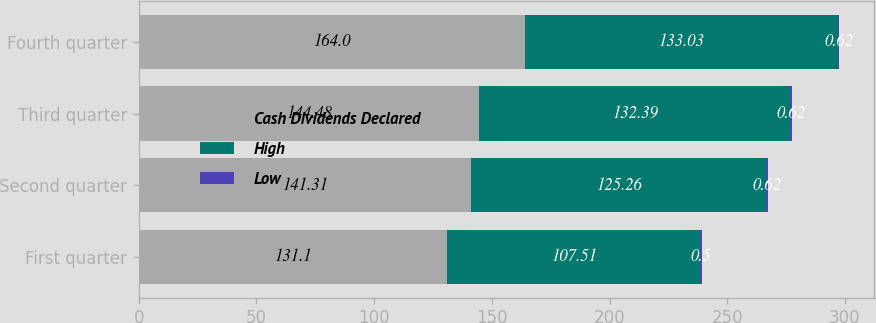Convert chart. <chart><loc_0><loc_0><loc_500><loc_500><stacked_bar_chart><ecel><fcel>First quarter<fcel>Second quarter<fcel>Third quarter<fcel>Fourth quarter<nl><fcel>Cash Dividends Declared<fcel>131.1<fcel>141.31<fcel>144.48<fcel>164<nl><fcel>High<fcel>107.51<fcel>125.26<fcel>132.39<fcel>133.03<nl><fcel>Low<fcel>0.5<fcel>0.62<fcel>0.62<fcel>0.62<nl></chart> 